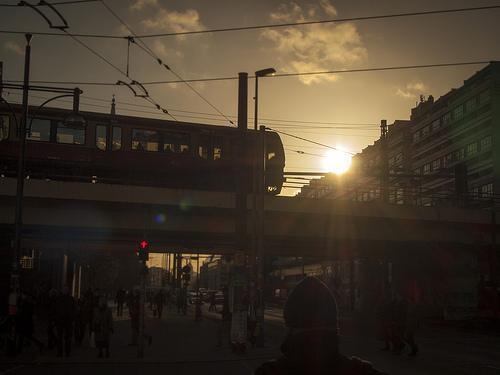How many trains are there?
Give a very brief answer. 1. 